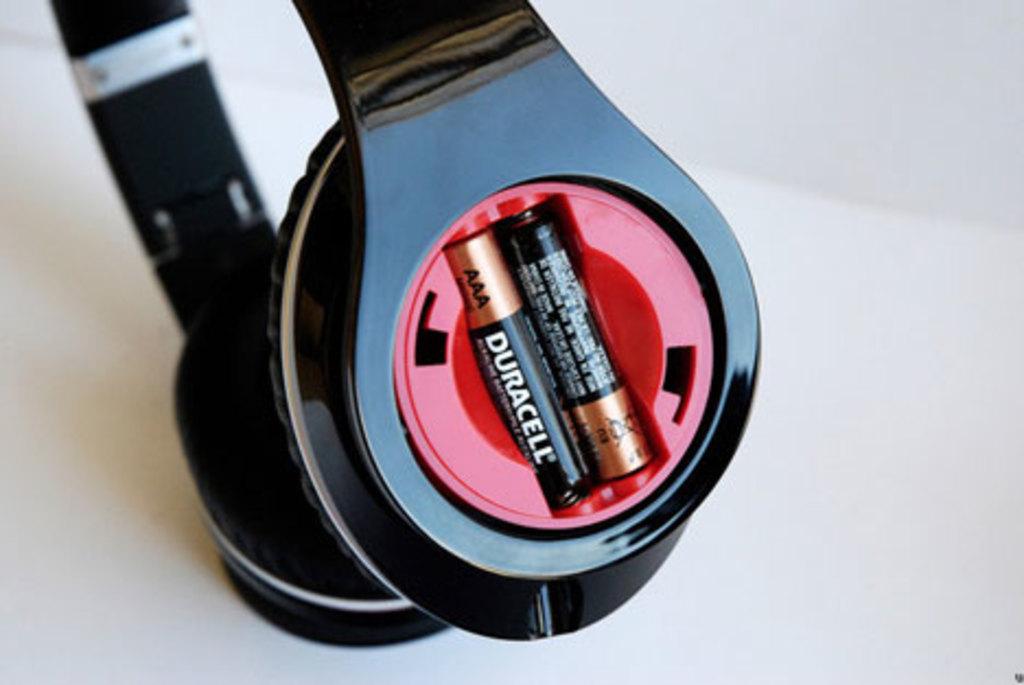What size are the batteries?
Your answer should be very brief. Aaa. What size battery does this show?
Give a very brief answer. Aaa. 